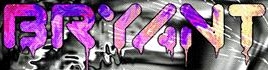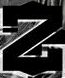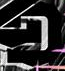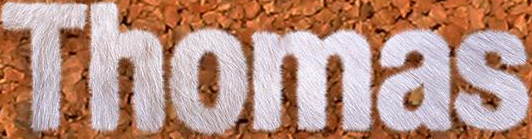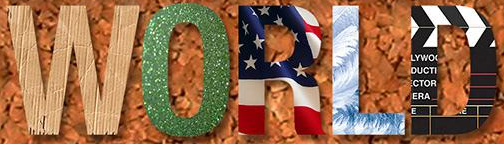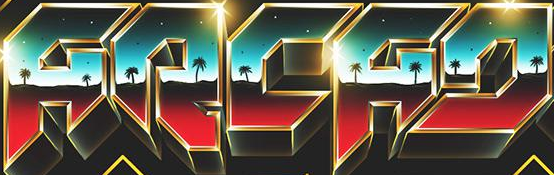What text is displayed in these images sequentially, separated by a semicolon? BRYANT; Z; D; Thomas; WORLD; ARCAD 